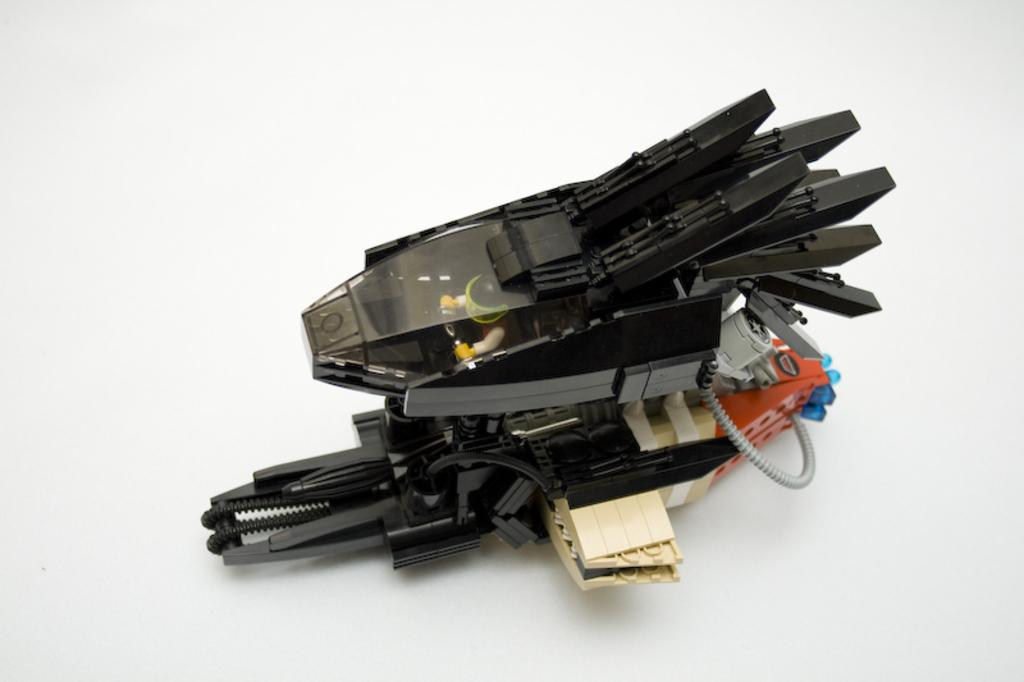What object can be seen in the image? There is a toy in the image. What is the color of the toy? The toy is black in color. How many pies are being baked by the toy in the image? There are no pies or baking activity depicted in the image; it only shows a black toy. What type of machine is the toy operating in the image? There is no machine present in the image; it only shows a black toy. 